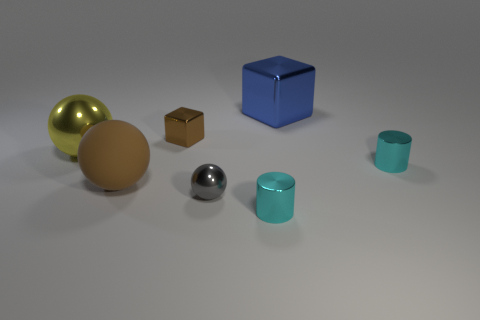Subtract all metal spheres. How many spheres are left? 1 Add 1 blue objects. How many objects exist? 8 Subtract all spheres. How many objects are left? 4 Add 6 big blue things. How many big blue things are left? 7 Add 3 large purple cylinders. How many large purple cylinders exist? 3 Subtract 0 purple spheres. How many objects are left? 7 Subtract all large green matte cubes. Subtract all large yellow metal spheres. How many objects are left? 6 